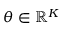Convert formula to latex. <formula><loc_0><loc_0><loc_500><loc_500>\boldsymbol \theta \in \mathbb { R } ^ { K }</formula> 